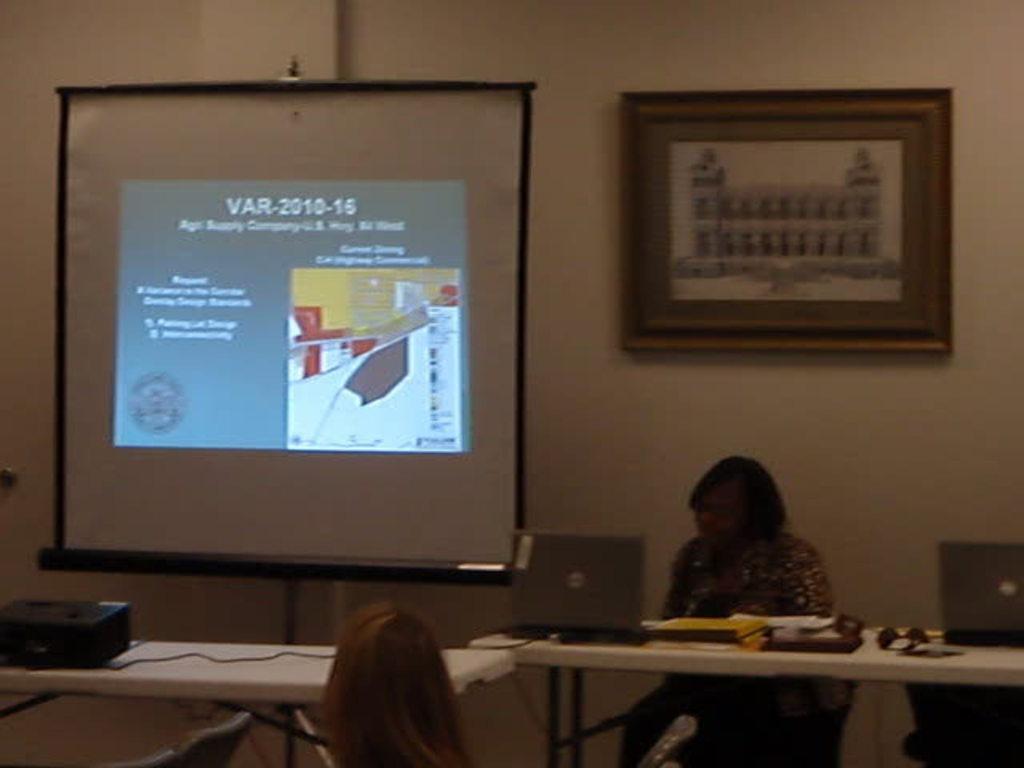In one or two sentences, can you explain what this image depicts? At the bottom of the image there are tables. On the tables we can see projector, laptops and some objects are there. A person is sitting on a chair, we can see a person head. In the background of the image we can see screen, photo frame, wall are there. 